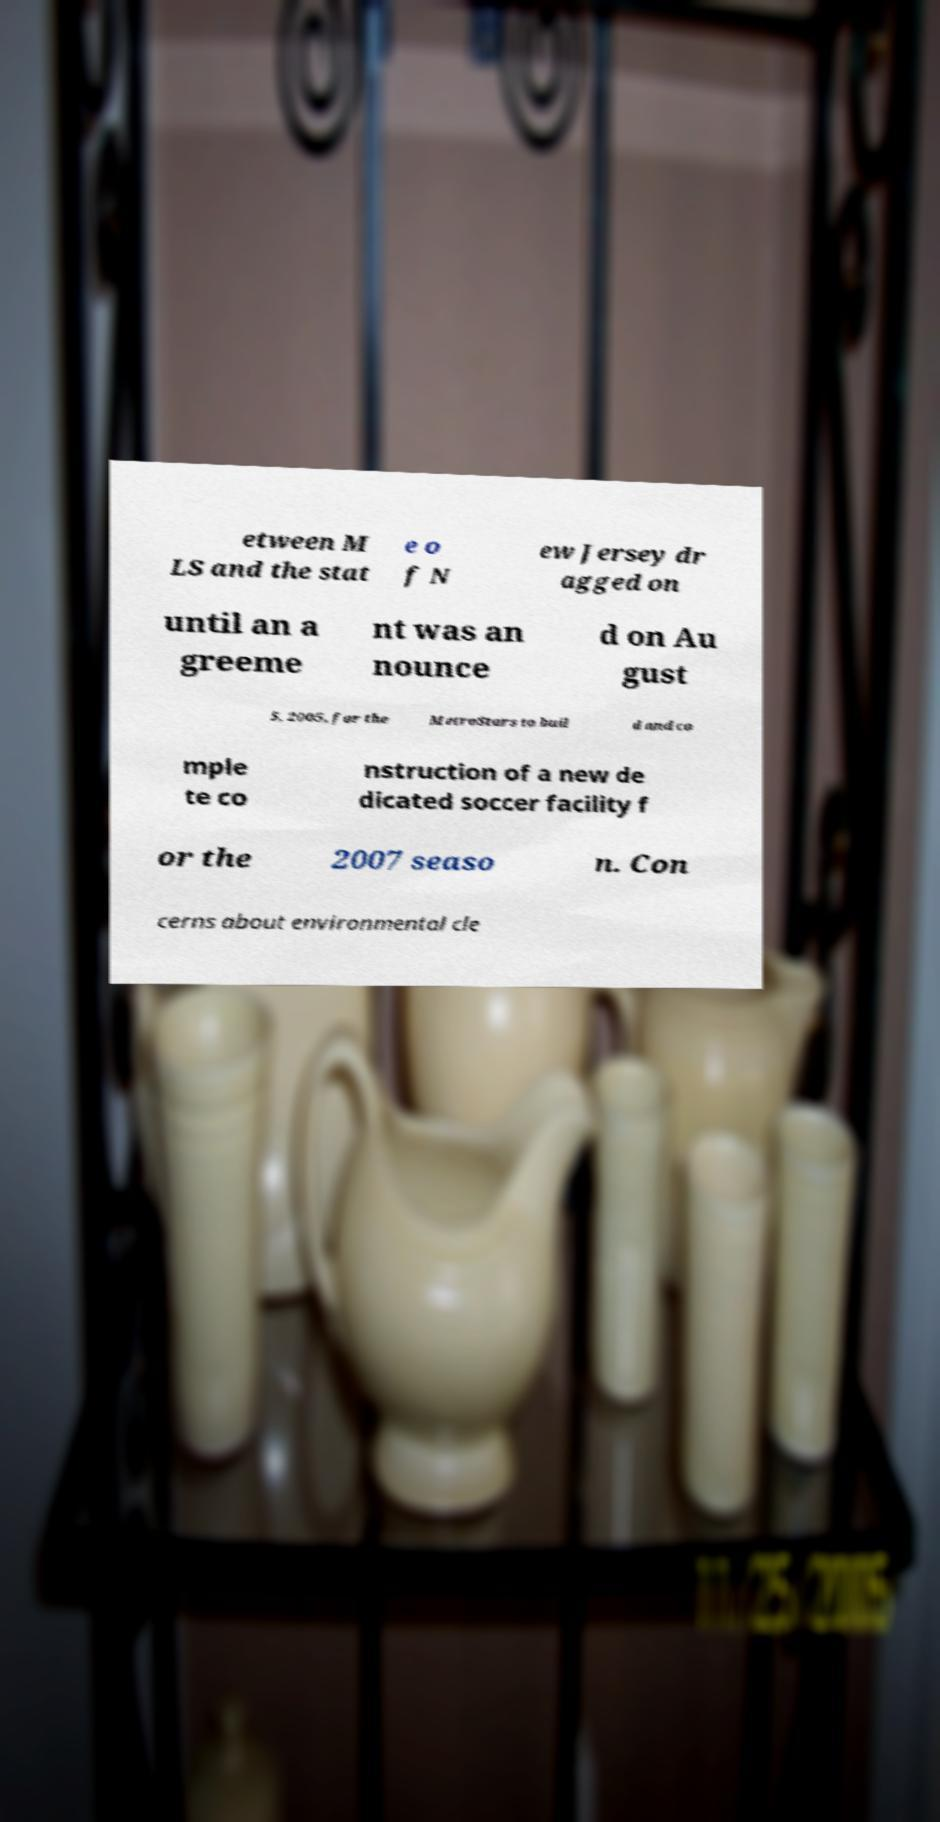Please identify and transcribe the text found in this image. etween M LS and the stat e o f N ew Jersey dr agged on until an a greeme nt was an nounce d on Au gust 5, 2005, for the MetroStars to buil d and co mple te co nstruction of a new de dicated soccer facility f or the 2007 seaso n. Con cerns about environmental cle 